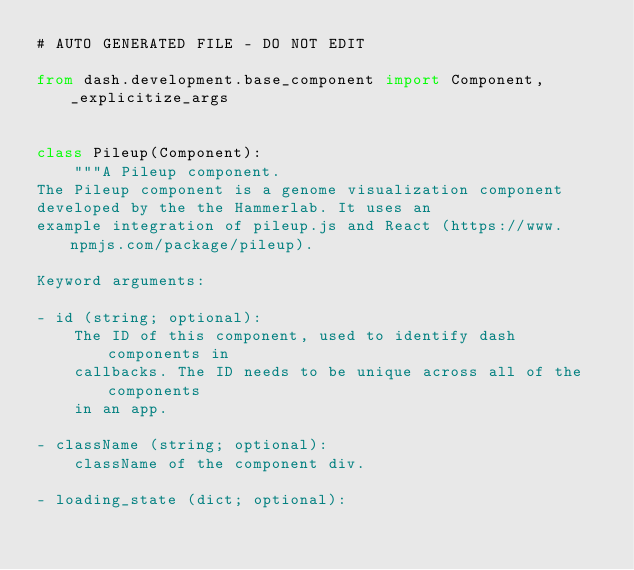<code> <loc_0><loc_0><loc_500><loc_500><_Python_># AUTO GENERATED FILE - DO NOT EDIT

from dash.development.base_component import Component, _explicitize_args


class Pileup(Component):
    """A Pileup component.
The Pileup component is a genome visualization component
developed by the the Hammerlab. It uses an
example integration of pileup.js and React (https://www.npmjs.com/package/pileup).

Keyword arguments:

- id (string; optional):
    The ID of this component, used to identify dash components in
    callbacks. The ID needs to be unique across all of the components
    in an app.

- className (string; optional):
    className of the component div.

- loading_state (dict; optional):</code> 